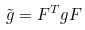Convert formula to latex. <formula><loc_0><loc_0><loc_500><loc_500>\tilde { g } = F ^ { T } g F</formula> 